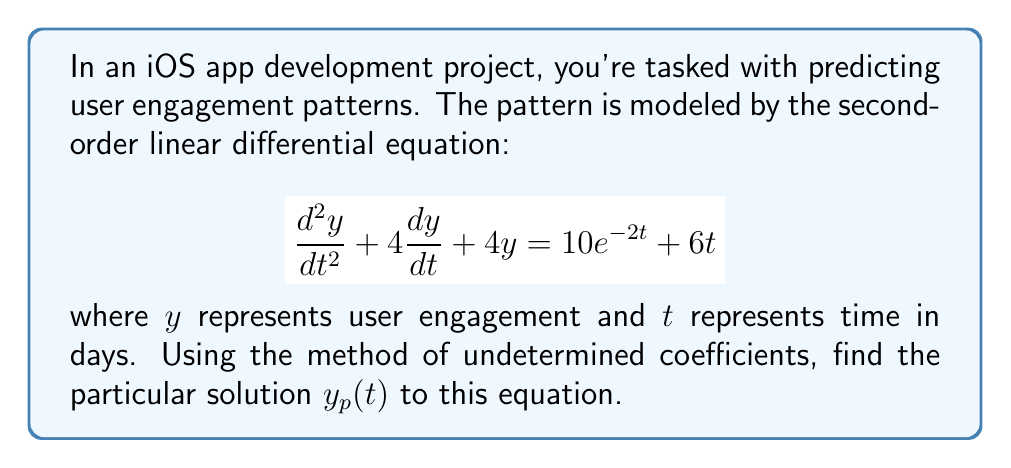Could you help me with this problem? To find the particular solution using the method of undetermined coefficients, we follow these steps:

1) First, identify the form of the particular solution based on the right-hand side of the equation:
   - For $10e^{-2t}$, we use $Ae^{-2t}$
   - For $6t$, we use $Bt + C$

   So, our particular solution will have the form:
   $$y_p(t) = Ae^{-2t} + Bt + C$$

2) Calculate the necessary derivatives:
   $$\frac{dy_p}{dt} = -2Ae^{-2t} + B$$
   $$\frac{d^2y_p}{dt^2} = 4Ae^{-2t}$$

3) Substitute these into the original equation:
   $$(4Ae^{-2t}) + 4(-2Ae^{-2t} + B) + 4(Ae^{-2t} + Bt + C) = 10e^{-2t} + 6t$$

4) Simplify:
   $$4Ae^{-2t} - 8Ae^{-2t} + 4B + 4Ae^{-2t} + 4Bt + 4C = 10e^{-2t} + 6t$$
   $$4B + 4Bt + 4C = 10e^{-2t} + 6t$$

5) Equate coefficients:
   $e^{-2t}$ terms: $0 = 10$, which is satisfied
   $t$ terms: $4B = 6$, so $B = \frac{3}{2}$
   Constant terms: $4B + 4C = 0$, so $C = -B = -\frac{3}{2}$

6) Therefore, the particular solution is:
   $$y_p(t) = \frac{3}{2}t - \frac{3}{2}$$
Answer: $y_p(t) = \frac{3}{2}t - \frac{3}{2}$ 